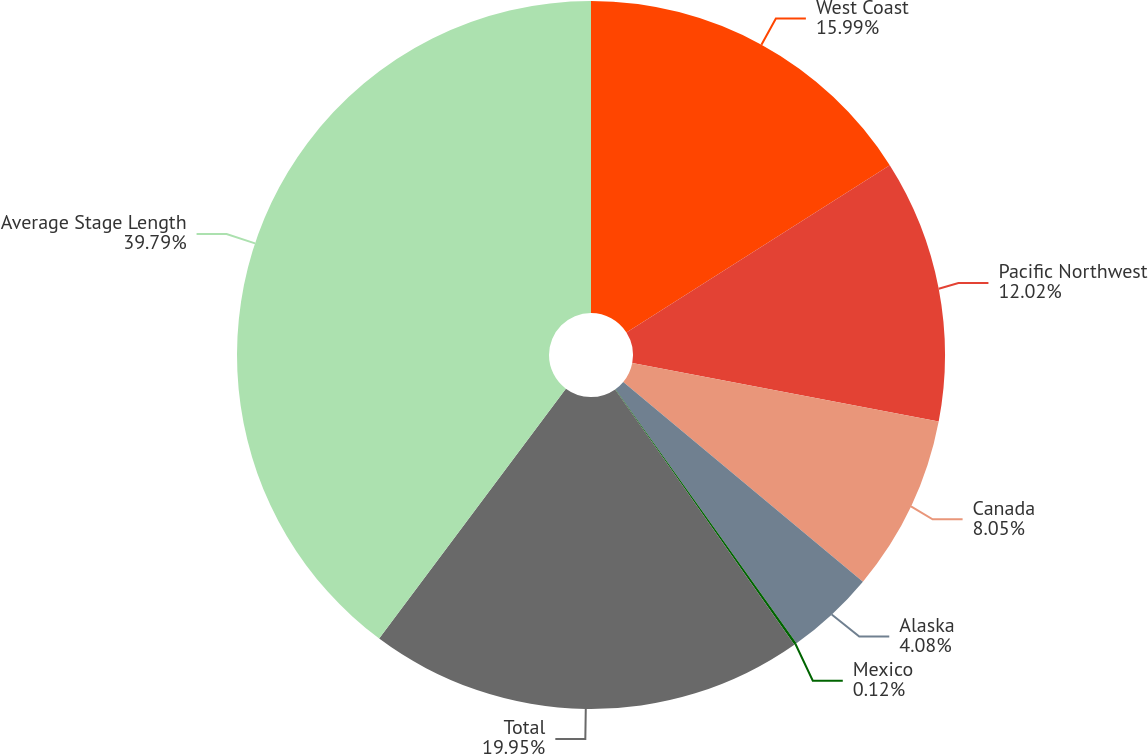<chart> <loc_0><loc_0><loc_500><loc_500><pie_chart><fcel>West Coast<fcel>Pacific Northwest<fcel>Canada<fcel>Alaska<fcel>Mexico<fcel>Total<fcel>Average Stage Length<nl><fcel>15.99%<fcel>12.02%<fcel>8.05%<fcel>4.08%<fcel>0.12%<fcel>19.95%<fcel>39.79%<nl></chart> 